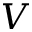<formula> <loc_0><loc_0><loc_500><loc_500>V</formula> 